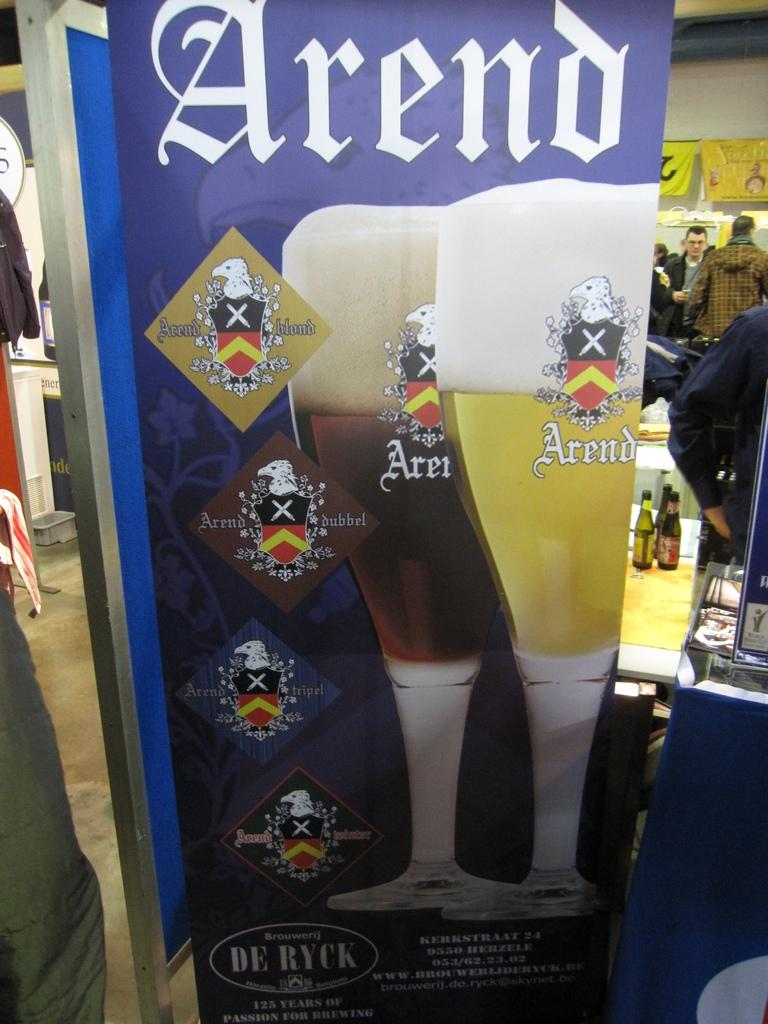What is the main object in the image? There is an advertising board in the image. Are there any people in the image? Yes, persons are present in the image. What else can be seen in the image besides the advertising board and people? Bottles are visible in the image. Is there a tiger roaming around the advertising board in the image? No, there is no tiger present in the image. What is the temperature of the hot item in the image? There is no hot item present in the image. 